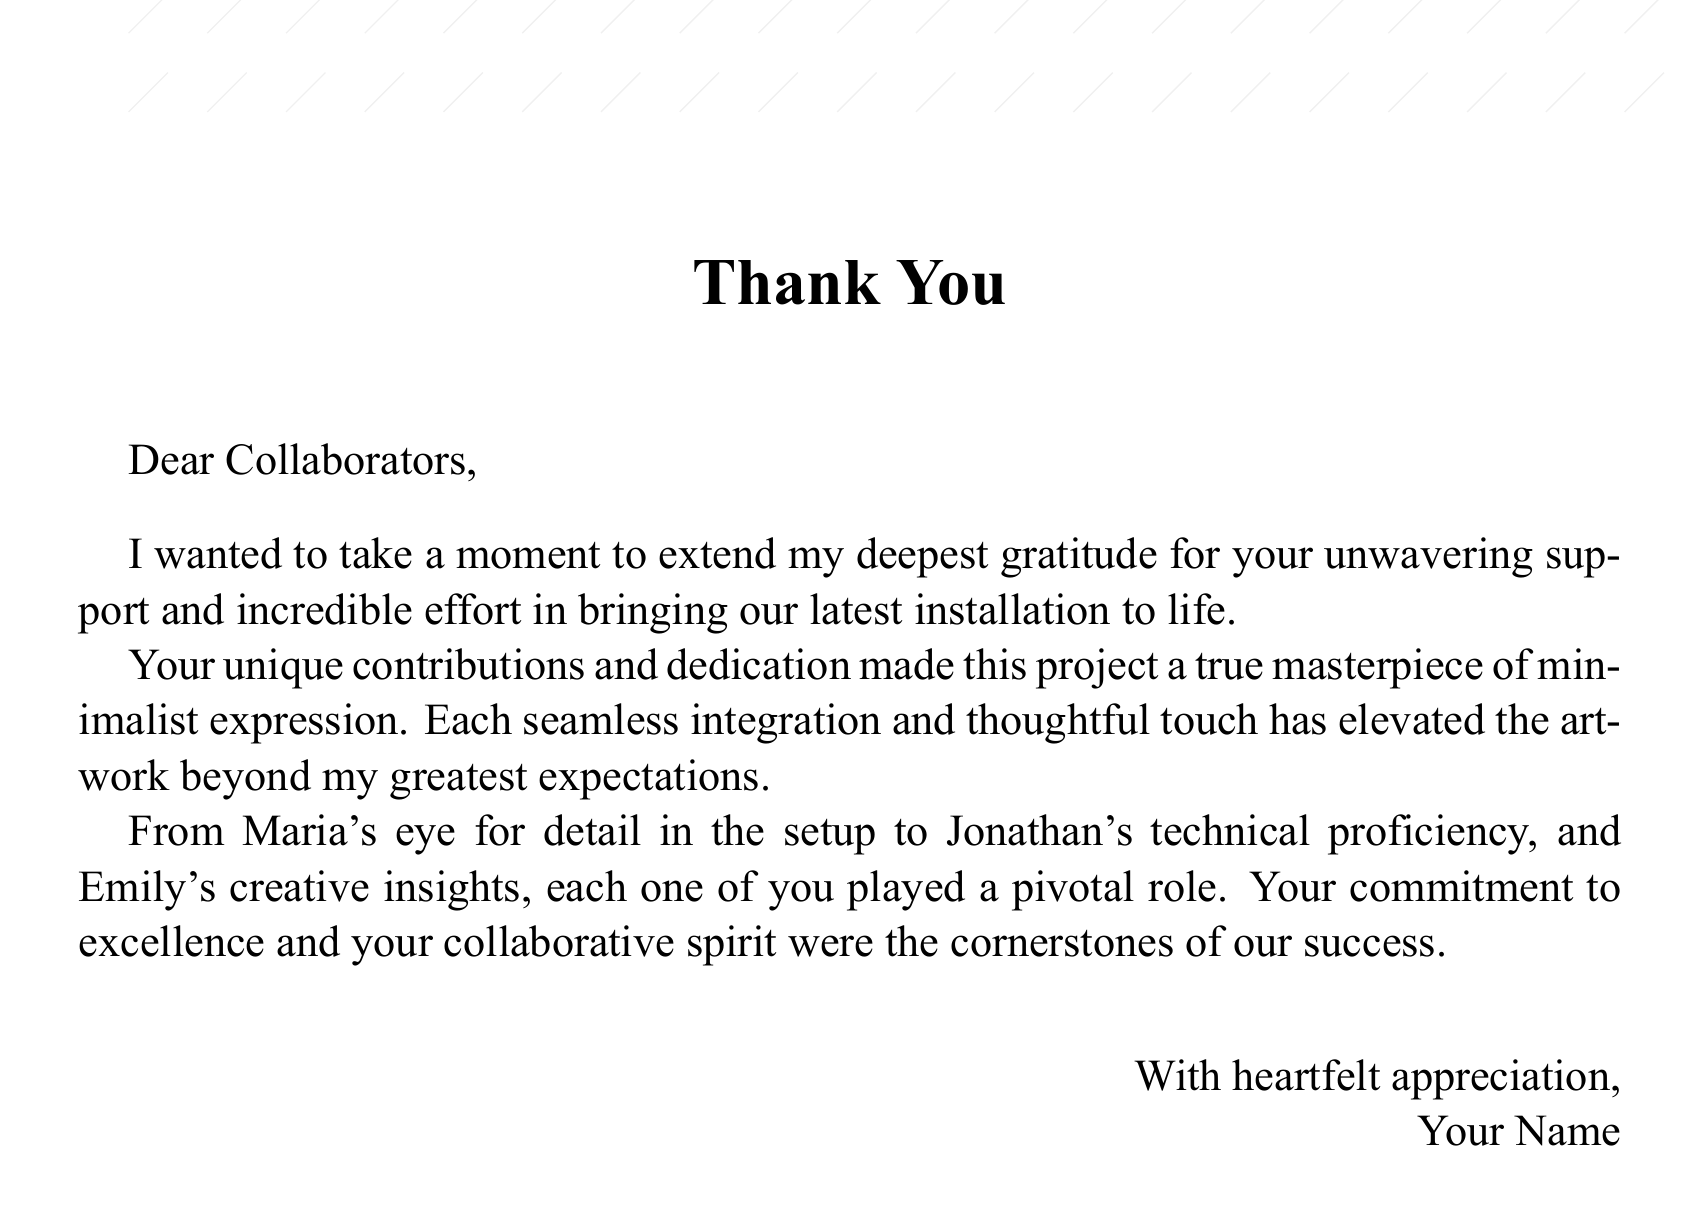What is the main title on the card? The main title is prominently displayed in a large font near the center of the card.
Answer: Thank You Who are addressed as collaborators in the card? The card specifically thanks the collaborators who assisted with the installation, mentioning their contributions.
Answer: Collaborators What were some contributions mentioned in the card? The card highlights specific skills and contributions from the individuals involved in the project.
Answer: Eye for detail, technical proficiency, creative insights What type of project is mentioned in the card? The context of the card centers around a specific creative endeavor that reflects a particular art style.
Answer: Installation What does the author express gratitude for? The author emphasizes the importance of support and effort from collaborators that made the project successful.
Answer: Unwavering support and incredible effort What is the tone of the message conveyed in the card? The card conveys a feeling of appreciation and warmth toward the collaborators.
Answer: Heartfelt appreciation In what style is the card designed? The card features a clean and simple aesthetic, focusing on minimalism with elegant design elements.
Answer: Minimalist How is the card's background described? The document specifies a characteristic of the card's visual design.
Answer: Crisp white backdrop 